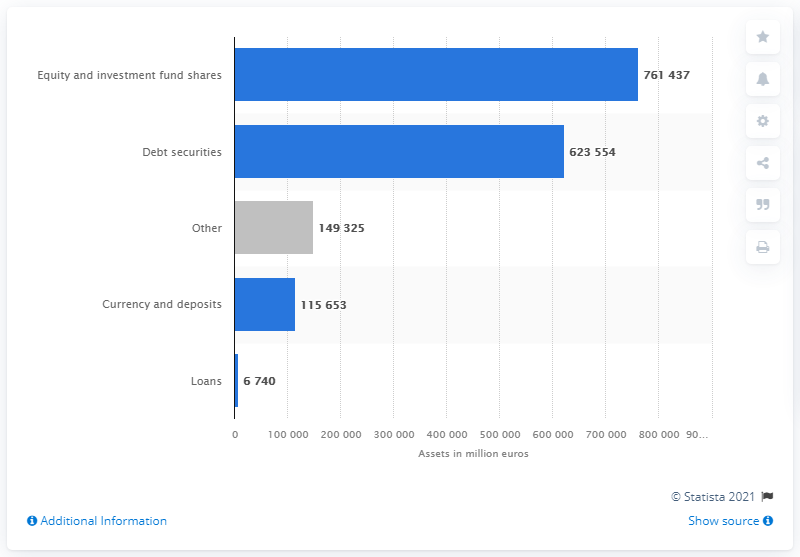Point out several critical features in this image. As of December 31, 2020, the total value of equity and investment fund shares owned by investment funds was approximately 761,437,000. The total value of financial assets held by investment funds in debt securities in France as of 2020 was approximately 623,554.. 